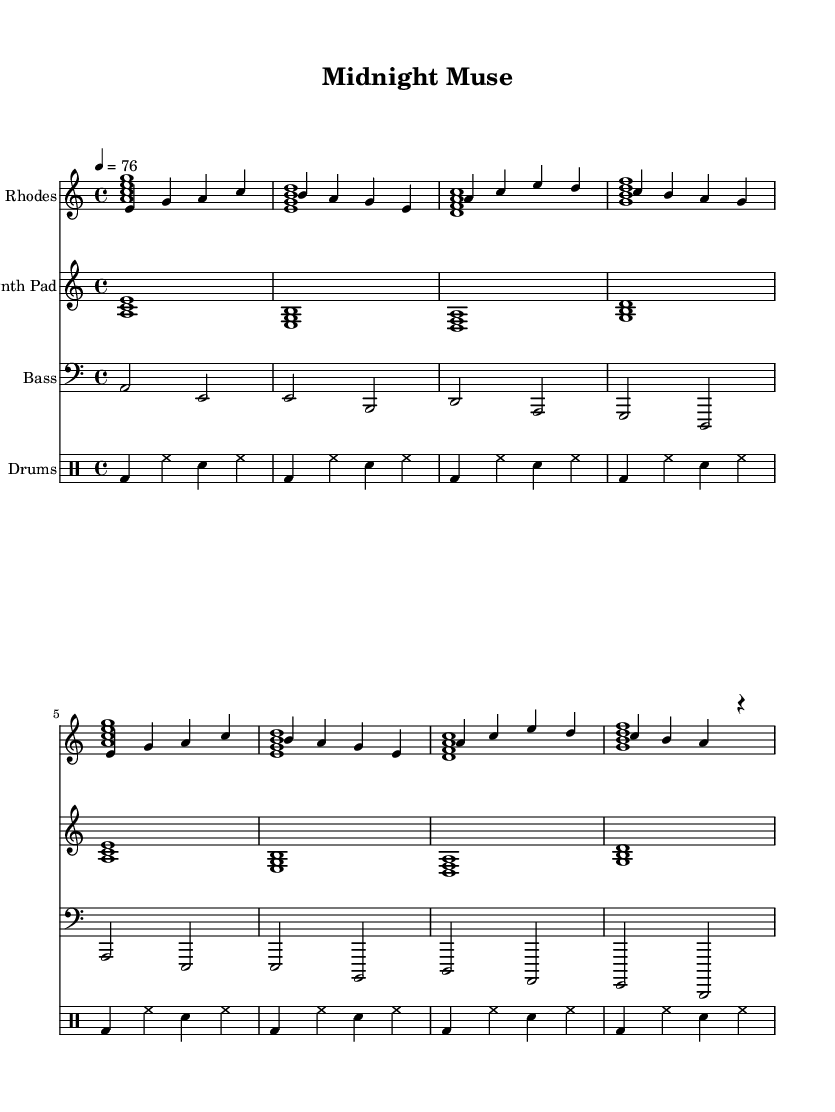What is the key signature of this music? The key signature indicated in the music is A minor, which has no sharps or flats, as seen in the clef notation and confirmed by the notes used throughout the piece.
Answer: A minor What is the time signature of this music? The time signature is found at the beginning of the sheet music, which is a 4/4 time, meaning there are four beats in each measure and the quarter note gets one beat.
Answer: 4/4 What is the tempo marking for this piece? The tempo marking, located at the beginning of the score, indicates a quarter note equals 76 beats per minute, specifying the speed at which the music should be played.
Answer: 76 How many measures are in the Rhodes piano part? By counting the individual sets of vertical bar lines that separate the rhythmic groupings, we see there are 8 measures total in the Rhodes piano part as it's defined within the lines and notations.
Answer: 8 What kind of chords are primarily used in the chords voice? The chord symbols given in the second iteration of the sheet music indicate the use of minor seventh and dominant seventh chords throughout the passage. The chords can be identified by the "m7" and "7" notations.
Answer: Minor seventh and dominant seventh What type of sound is likely produced by the synthesizer pad? Given the context, the synth pad uses sustained chords indicated by whole notes, creating a smooth, lush texture typical of ambient music in chill lounge settings, designed to enhance the relaxing atmosphere.
Answer: Ambient What is the function of the bass in this composition? The bass part provides a foundational harmonic structure to the piece, playing root notes of the chords in a sustained manner, solidifying the overall harmonic progression and complementing the upper voices.
Answer: Harmonic foundation 